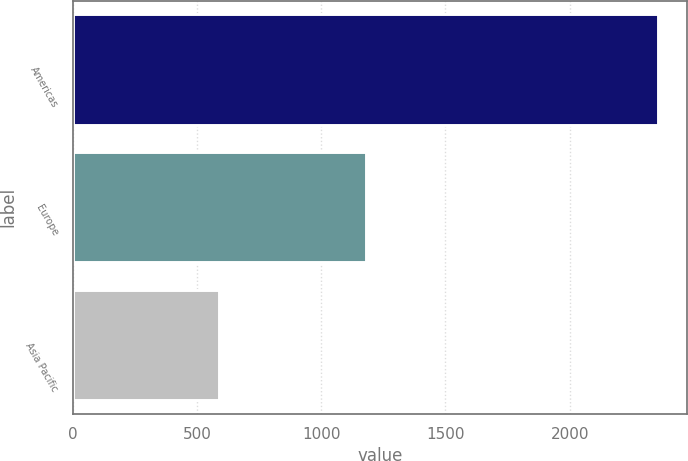<chart> <loc_0><loc_0><loc_500><loc_500><bar_chart><fcel>Americas<fcel>Europe<fcel>Asia Pacific<nl><fcel>2353.9<fcel>1179.1<fcel>588.1<nl></chart> 